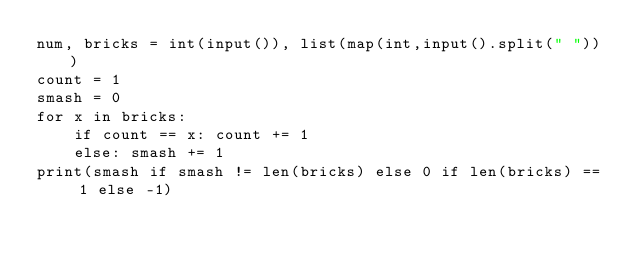<code> <loc_0><loc_0><loc_500><loc_500><_Python_>num, bricks = int(input()), list(map(int,input().split(" ")))
count = 1
smash = 0
for x in bricks:
    if count == x: count += 1
    else: smash += 1
print(smash if smash != len(bricks) else 0 if len(bricks) == 1 else -1)</code> 